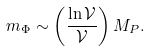<formula> <loc_0><loc_0><loc_500><loc_500>m _ { \Phi } \sim \left ( \frac { \ln \mathcal { V } } { \mathcal { V } } \right ) M _ { P } .</formula> 